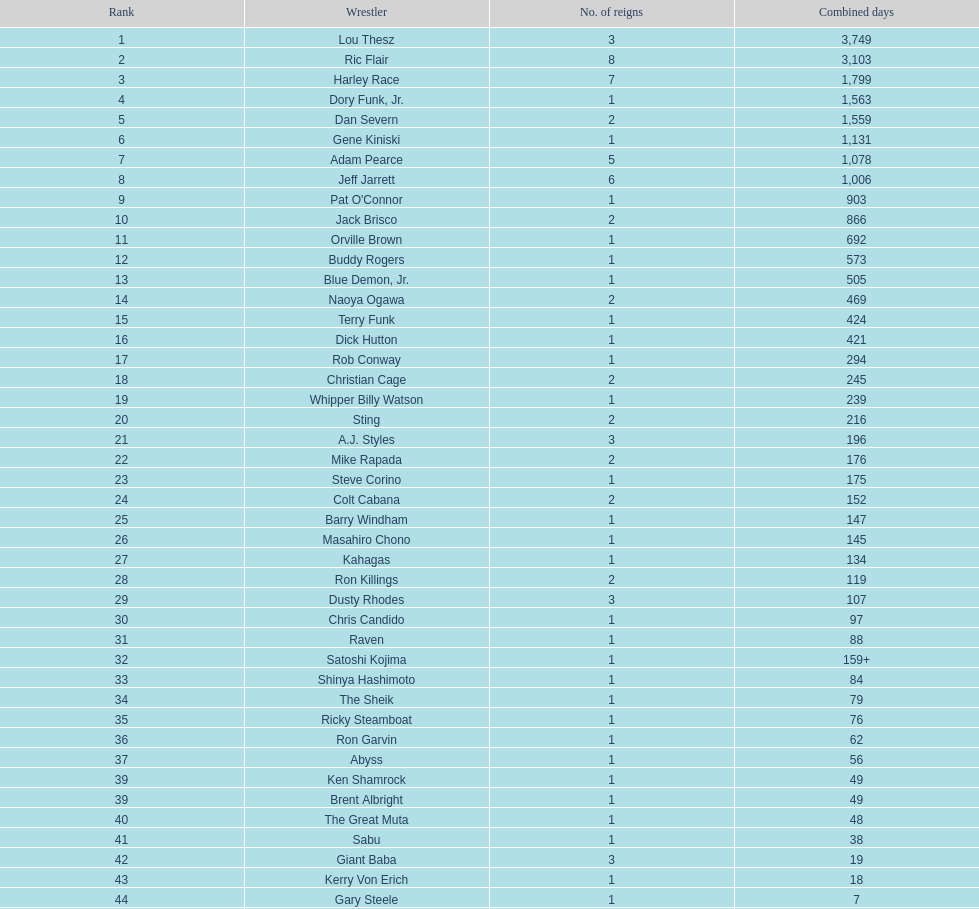Which professional wrestler has had the most number of reigns as nwa world heavyweight champion? Ric Flair. 